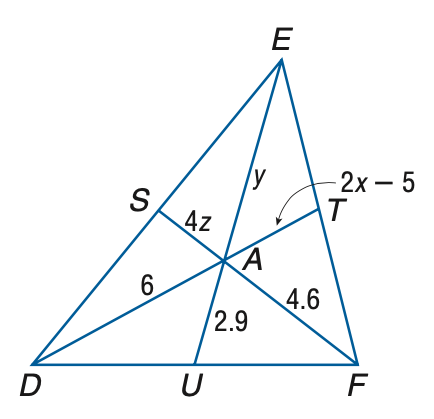Answer the mathemtical geometry problem and directly provide the correct option letter.
Question: Points S, T, and U are the midpoints of D E, E F, and D F, respectively. Find z.
Choices: A: 0.383 B: 0.575 C: 1.15 D: 2.875 B 